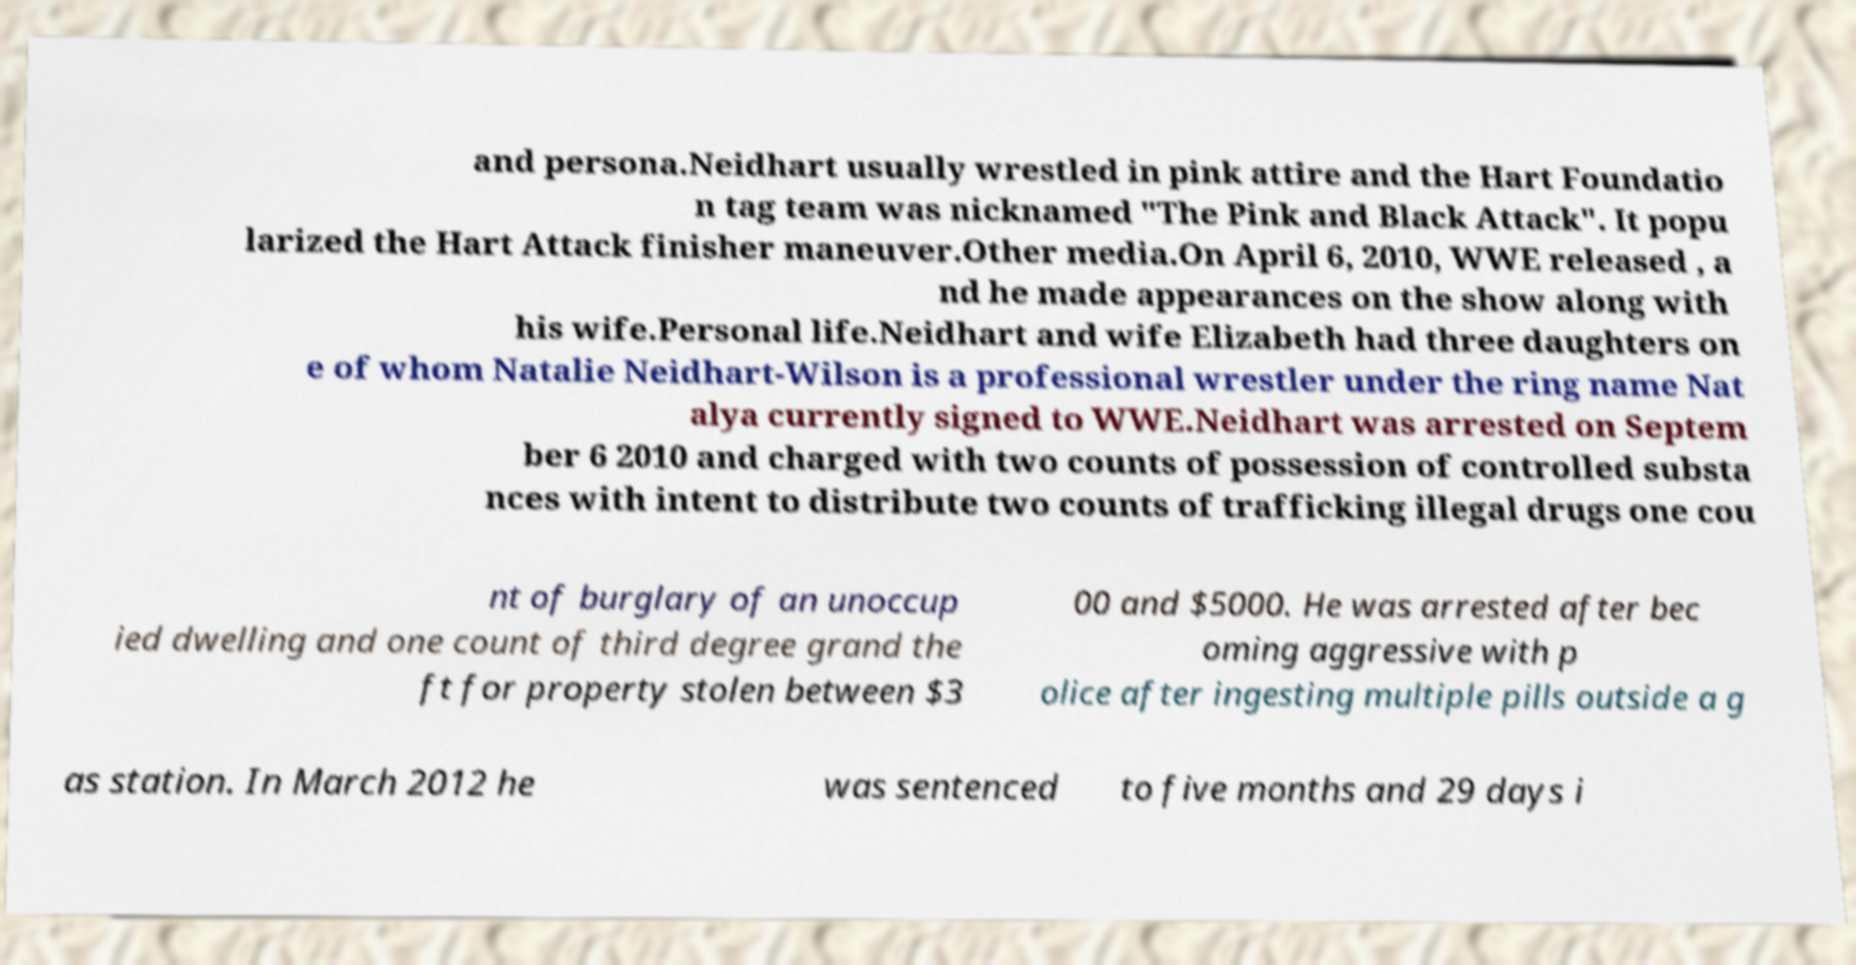What messages or text are displayed in this image? I need them in a readable, typed format. and persona.Neidhart usually wrestled in pink attire and the Hart Foundatio n tag team was nicknamed "The Pink and Black Attack". It popu larized the Hart Attack finisher maneuver.Other media.On April 6, 2010, WWE released , a nd he made appearances on the show along with his wife.Personal life.Neidhart and wife Elizabeth had three daughters on e of whom Natalie Neidhart-Wilson is a professional wrestler under the ring name Nat alya currently signed to WWE.Neidhart was arrested on Septem ber 6 2010 and charged with two counts of possession of controlled substa nces with intent to distribute two counts of trafficking illegal drugs one cou nt of burglary of an unoccup ied dwelling and one count of third degree grand the ft for property stolen between $3 00 and $5000. He was arrested after bec oming aggressive with p olice after ingesting multiple pills outside a g as station. In March 2012 he was sentenced to five months and 29 days i 